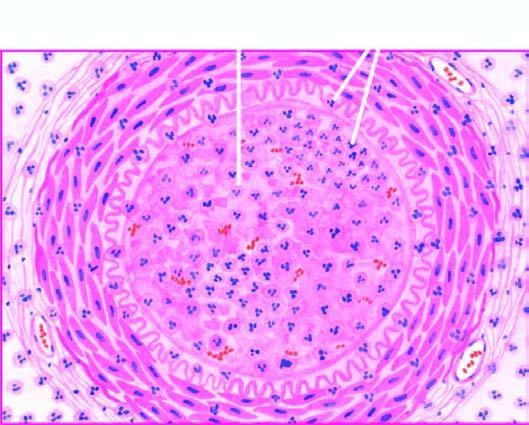s the lumen occluded by a thrombus containing microabscesses?
Answer the question using a single word or phrase. Yes 